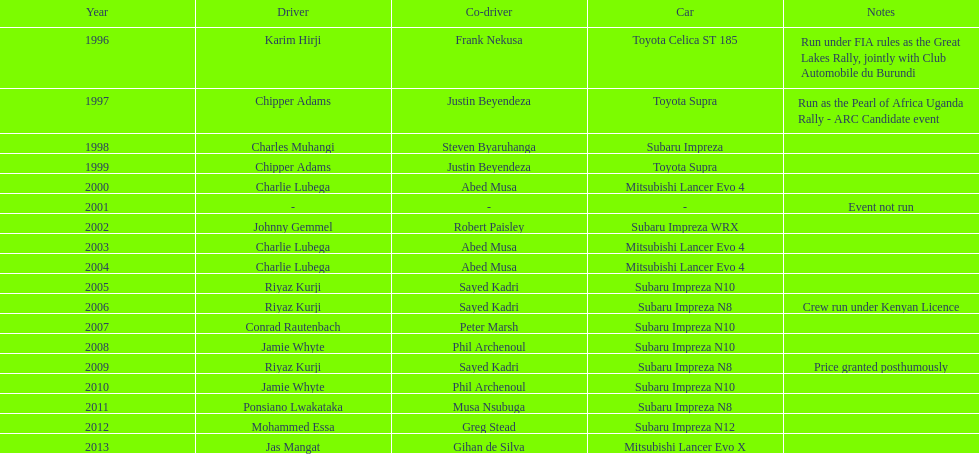Can you name the only driver to secure consecutive triumphs? Charlie Lubega. 